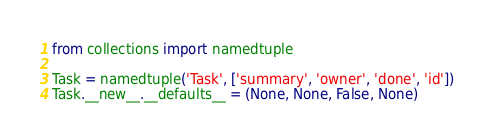<code> <loc_0><loc_0><loc_500><loc_500><_Python_>from collections import namedtuple

Task = namedtuple('Task', ['summary', 'owner', 'done', 'id'])
Task.__new__.__defaults__ = (None, None, False, None)
</code> 